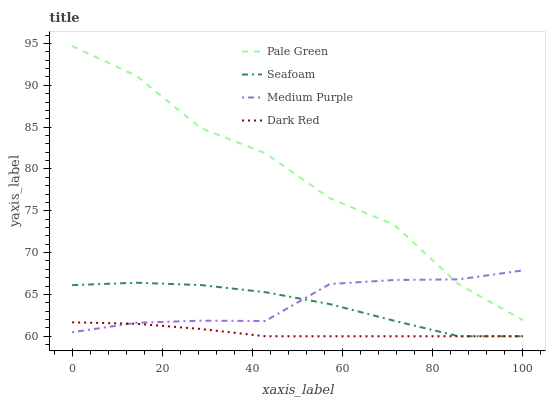Does Dark Red have the minimum area under the curve?
Answer yes or no. Yes. Does Pale Green have the maximum area under the curve?
Answer yes or no. Yes. Does Pale Green have the minimum area under the curve?
Answer yes or no. No. Does Dark Red have the maximum area under the curve?
Answer yes or no. No. Is Dark Red the smoothest?
Answer yes or no. Yes. Is Pale Green the roughest?
Answer yes or no. Yes. Is Pale Green the smoothest?
Answer yes or no. No. Is Dark Red the roughest?
Answer yes or no. No. Does Dark Red have the lowest value?
Answer yes or no. Yes. Does Pale Green have the lowest value?
Answer yes or no. No. Does Pale Green have the highest value?
Answer yes or no. Yes. Does Dark Red have the highest value?
Answer yes or no. No. Is Dark Red less than Pale Green?
Answer yes or no. Yes. Is Pale Green greater than Seafoam?
Answer yes or no. Yes. Does Dark Red intersect Medium Purple?
Answer yes or no. Yes. Is Dark Red less than Medium Purple?
Answer yes or no. No. Is Dark Red greater than Medium Purple?
Answer yes or no. No. Does Dark Red intersect Pale Green?
Answer yes or no. No. 